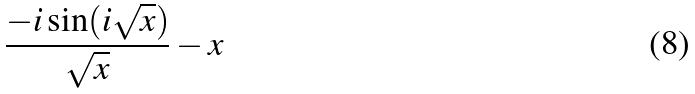<formula> <loc_0><loc_0><loc_500><loc_500>\frac { - i \sin ( i \sqrt { x } ) } { \sqrt { x } } - x</formula> 